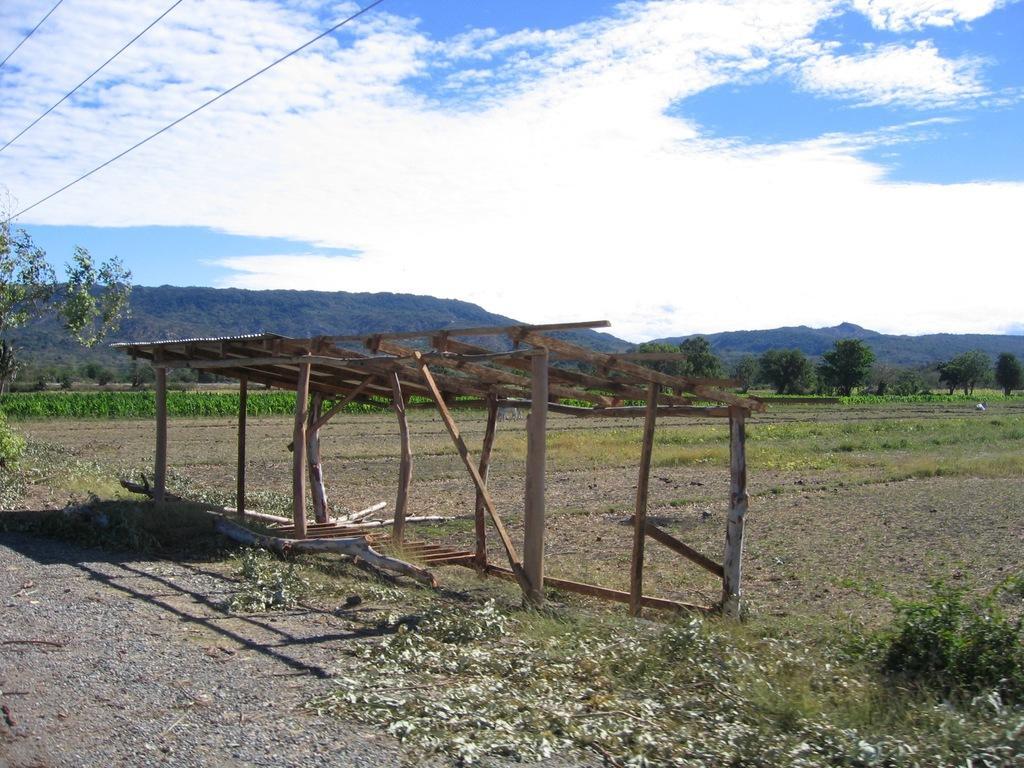Describe this image in one or two sentences. In this image we can see a shed build with some wooden poles. We can also see the pathway, grass, some plants and a group of trees. On the backside we can see the hills and the sky which looks cloudy. 